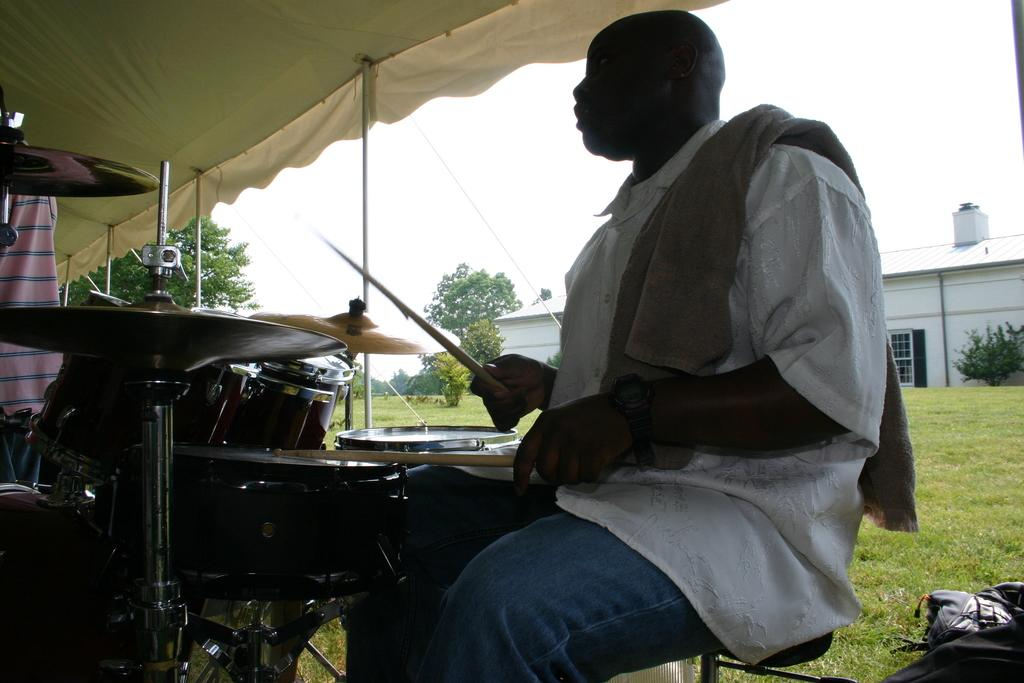What is the man in the image doing? The man is playing drums in the image. What type of surface is the man playing drums on? The provided facts do not specify the surface the man is playing drums on. What can be seen in the background of the image? There is grass, a house, plants, trees, and the sky visible in the image. What type of quilt is draped over the man playing drums in the image? There is no quilt present in the image; the man is playing drums without any covering. 